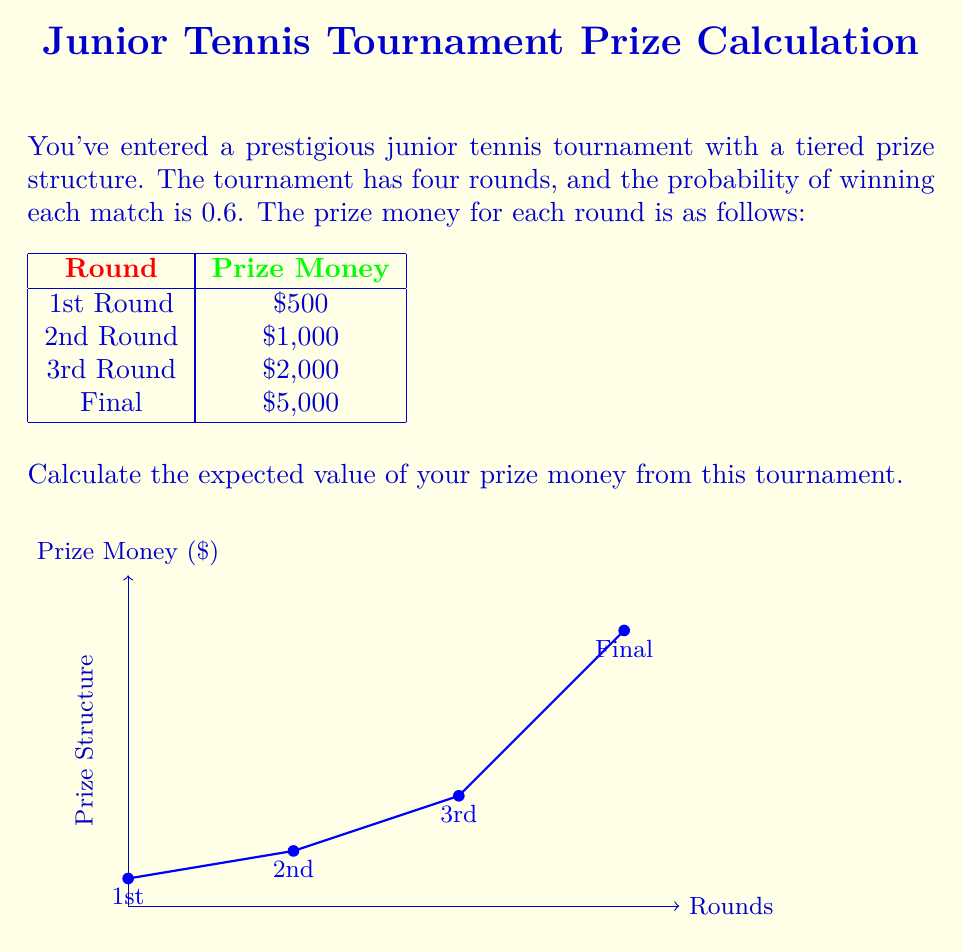Could you help me with this problem? Let's approach this step-by-step:

1) First, we need to calculate the probability of reaching each round:
   - 1st Round: 100% = 1
   - 2nd Round: 0.6
   - 3rd Round: $0.6 \times 0.6 = 0.6^2 = 0.36$
   - Final: $0.6 \times 0.6 \times 0.6 = 0.6^3 = 0.216$

2) Now, we need to calculate the probability of winning each prize:
   - $500: 1 - 0.6 = 0.4$ (probability of losing in the 1st round)
   - $1,000: 0.6 - 0.36 = 0.24$ (probability of winning 1st but losing 2nd)
   - $2,000: 0.36 - 0.216 = 0.144$ (probability of winning 2nd but losing 3rd)
   - $5,000: 0.216$ (probability of reaching and winning the final)

3) Now we can calculate the expected value using the formula:
   $E = \sum_{i=1}^n p_i \times x_i$
   where $p_i$ is the probability of each outcome and $x_i$ is the value of each outcome.

4) Let's substitute our values:
   $E = (0.4 \times 500) + (0.24 \times 1000) + (0.144 \times 2000) + (0.216 \times 5000)$

5) Calculate:
   $E = 200 + 240 + 288 + 1080 = 1808$

Therefore, the expected value of your prize money is $1,808.
Answer: $1,808 